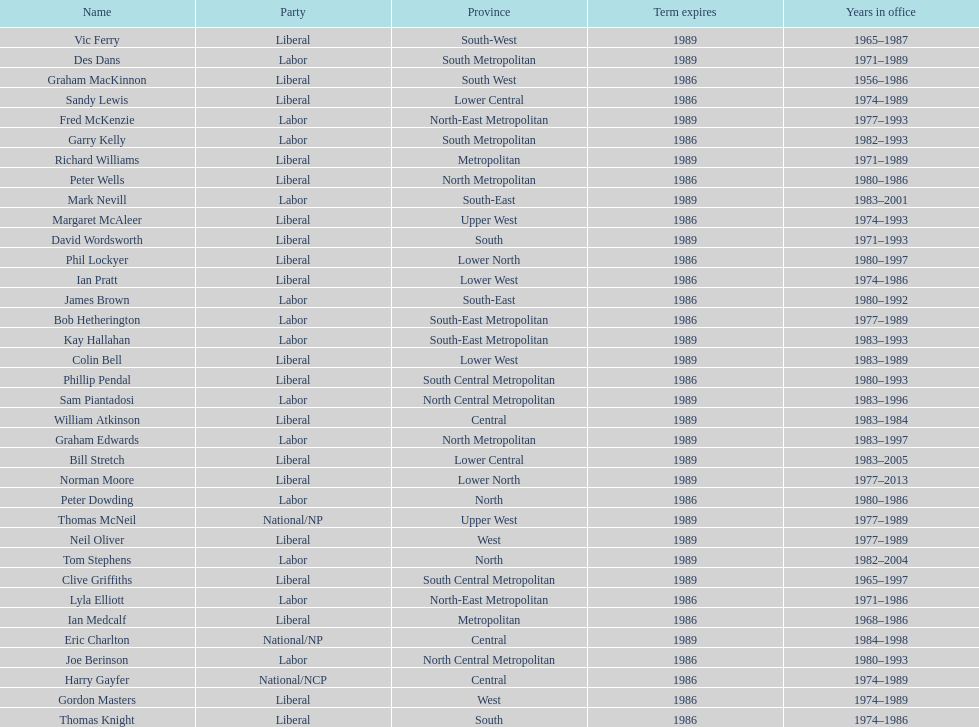Which party has the most membership? Liberal. 